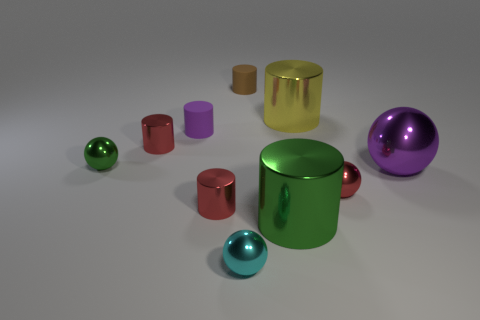Subtract all purple cylinders. How many cylinders are left? 5 Subtract all brown rubber cylinders. How many cylinders are left? 5 Subtract all purple balls. Subtract all gray cylinders. How many balls are left? 3 Subtract all cylinders. How many objects are left? 4 Subtract 0 red blocks. How many objects are left? 10 Subtract all purple metallic spheres. Subtract all red cylinders. How many objects are left? 7 Add 1 small cylinders. How many small cylinders are left? 5 Add 3 cyan things. How many cyan things exist? 4 